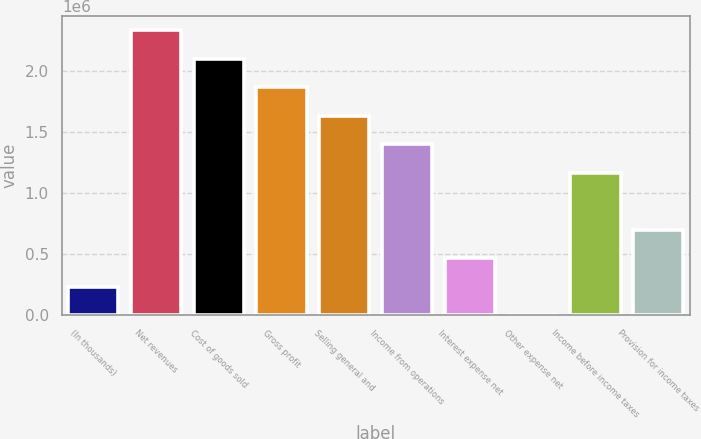Convert chart. <chart><loc_0><loc_0><loc_500><loc_500><bar_chart><fcel>(In thousands)<fcel>Net revenues<fcel>Cost of goods sold<fcel>Gross profit<fcel>Selling general and<fcel>Income from operations<fcel>Interest expense net<fcel>Other expense net<fcel>Income before income taxes<fcel>Provision for income taxes<nl><fcel>234260<fcel>2.33205e+06<fcel>2.09896e+06<fcel>1.86588e+06<fcel>1.63279e+06<fcel>1.3997e+06<fcel>467348<fcel>1172<fcel>1.16661e+06<fcel>700436<nl></chart> 